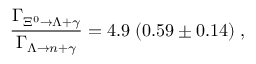<formula> <loc_0><loc_0><loc_500><loc_500>\frac { \Gamma _ { \Xi ^ { 0 } \rightarrow \Lambda + \gamma } } { \Gamma _ { \Lambda \rightarrow n + \gamma } } = 4 . 9 \, ( 0 . 5 9 \pm 0 . 1 4 ) \, ,</formula> 